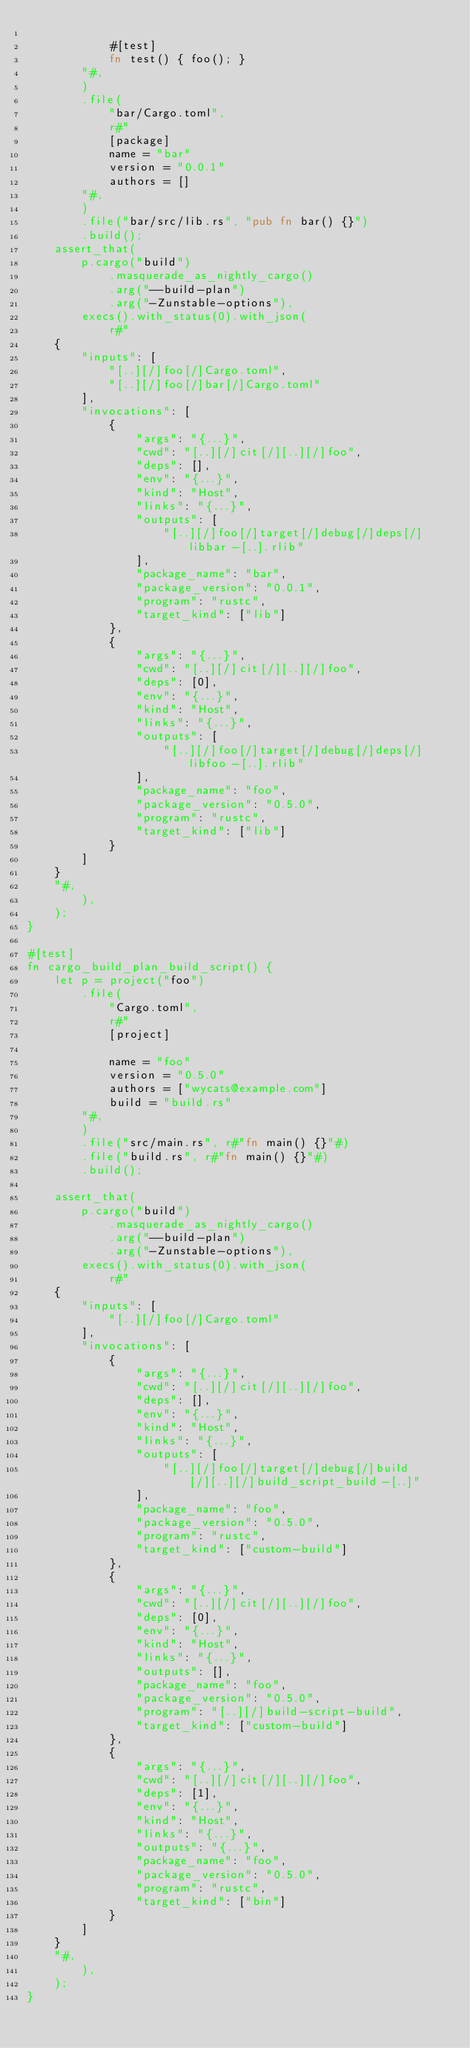<code> <loc_0><loc_0><loc_500><loc_500><_Rust_>
            #[test]
            fn test() { foo(); }
        "#,
        )
        .file(
            "bar/Cargo.toml",
            r#"
            [package]
            name = "bar"
            version = "0.0.1"
            authors = []
        "#,
        )
        .file("bar/src/lib.rs", "pub fn bar() {}")
        .build();
    assert_that(
        p.cargo("build")
            .masquerade_as_nightly_cargo()
            .arg("--build-plan")
            .arg("-Zunstable-options"),
        execs().with_status(0).with_json(
            r#"
    {
        "inputs": [
            "[..][/]foo[/]Cargo.toml",
            "[..][/]foo[/]bar[/]Cargo.toml"
        ],
        "invocations": [
            {
                "args": "{...}",
                "cwd": "[..][/]cit[/][..][/]foo",
                "deps": [],
                "env": "{...}",
                "kind": "Host",
                "links": "{...}",
                "outputs": [
                    "[..][/]foo[/]target[/]debug[/]deps[/]libbar-[..].rlib"
                ],
                "package_name": "bar",
                "package_version": "0.0.1",
                "program": "rustc",
                "target_kind": ["lib"]
            },
            {
                "args": "{...}",
                "cwd": "[..][/]cit[/][..][/]foo",
                "deps": [0],
                "env": "{...}",
                "kind": "Host",
                "links": "{...}",
                "outputs": [
                    "[..][/]foo[/]target[/]debug[/]deps[/]libfoo-[..].rlib"
                ],
                "package_name": "foo",
                "package_version": "0.5.0",
                "program": "rustc",
                "target_kind": ["lib"]
            }
        ]
    }
    "#,
        ),
    );
}

#[test]
fn cargo_build_plan_build_script() {
    let p = project("foo")
        .file(
            "Cargo.toml",
            r#"
            [project]

            name = "foo"
            version = "0.5.0"
            authors = ["wycats@example.com"]
            build = "build.rs"
        "#,
        )
        .file("src/main.rs", r#"fn main() {}"#)
        .file("build.rs", r#"fn main() {}"#)
        .build();

    assert_that(
        p.cargo("build")
            .masquerade_as_nightly_cargo()
            .arg("--build-plan")
            .arg("-Zunstable-options"),
        execs().with_status(0).with_json(
            r#"
    {
        "inputs": [
            "[..][/]foo[/]Cargo.toml"
        ],
        "invocations": [
            {
                "args": "{...}",
                "cwd": "[..][/]cit[/][..][/]foo",
                "deps": [],
                "env": "{...}",
                "kind": "Host",
                "links": "{...}",
                "outputs": [
                    "[..][/]foo[/]target[/]debug[/]build[/][..][/]build_script_build-[..]"
                ],
                "package_name": "foo",
                "package_version": "0.5.0",
                "program": "rustc",
                "target_kind": ["custom-build"]
            },
            {
                "args": "{...}",
                "cwd": "[..][/]cit[/][..][/]foo",
                "deps": [0],
                "env": "{...}",
                "kind": "Host",
                "links": "{...}",
                "outputs": [],
                "package_name": "foo",
                "package_version": "0.5.0",
                "program": "[..][/]build-script-build",
                "target_kind": ["custom-build"]
            },
            {
                "args": "{...}",
                "cwd": "[..][/]cit[/][..][/]foo",
                "deps": [1],
                "env": "{...}",
                "kind": "Host",
                "links": "{...}",
                "outputs": "{...}",
                "package_name": "foo",
                "package_version": "0.5.0",
                "program": "rustc",
                "target_kind": ["bin"]
            }
        ]
    }
    "#,
        ),
    );
}
</code> 